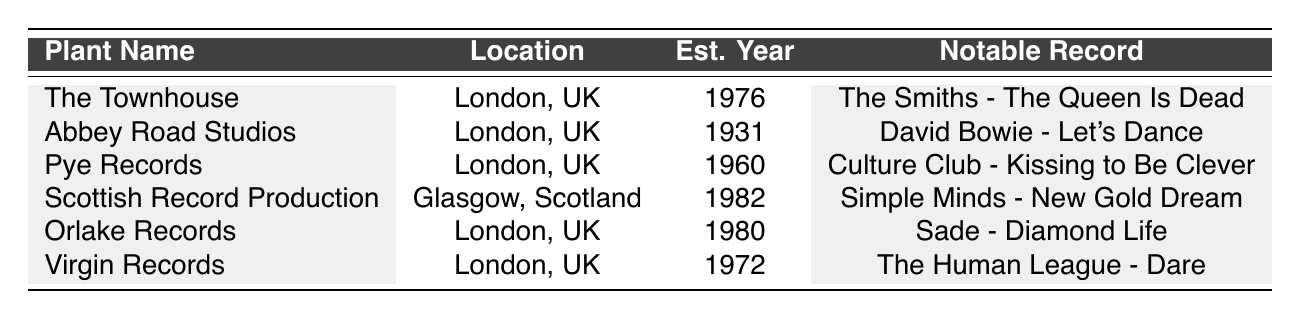What is the location of Abbey Road Studios? Abbey Road Studios is listed in the table with its location specified as London, UK.
Answer: London, UK Which record was produced by The Townhouse? The Townhouse has a notable record listed as "The Smiths - The Queen Is Dead."
Answer: The Smiths - The Queen Is Dead How many vinyl pressing plants were established after 1980? Looking at the establishment years, Scottish Record Production (1982) is the only plant established after 1980.
Answer: 1 Is Pye Records located in Scotland? Pye Records' location is listed as London, UK, which confirms it is not in Scotland.
Answer: No What is the average year established among all the plants listed? The establishment years are 1931, 1960, 1972, 1976, 1980, and 1982. Their sum is 1931 + 1960 + 1972 + 1976 + 1980 + 1982 = 11803, and there are 6 plants, so the average is 11803/6 ≈ 1967.17, meaning the average year is approximately 1967.
Answer: 1967 Which pressing plant has the oldest establishment year? By comparing the years established, Abbey Road Studios (1931) is the oldest.
Answer: Abbey Road Studios How many notable records are associated with Virgin Records? Virgin Records has two notable records listed: "Bran Van 3000 - Glee" and "The Human League - Dare."
Answer: 2 Which plant produced records for both Sade and Eurythmics? The notable records associated with Orlake Records include both "Sade - Diamond Life" and "Eurythmics - Sweet Dreams".
Answer: Orlake Records Does Scottish Record Production use Analog Pressing technology? The technologies used by Scottish Record Production include Direct Metal Mastering and Vinyl Pressing, but Analog Pressing is not mentioned.
Answer: No Which vinyl pressing plant produced Simple Minds' "New Gold Dream"? The table indicates that "New Gold Dream" was produced by Scottish Record Production.
Answer: Scottish Record Production 